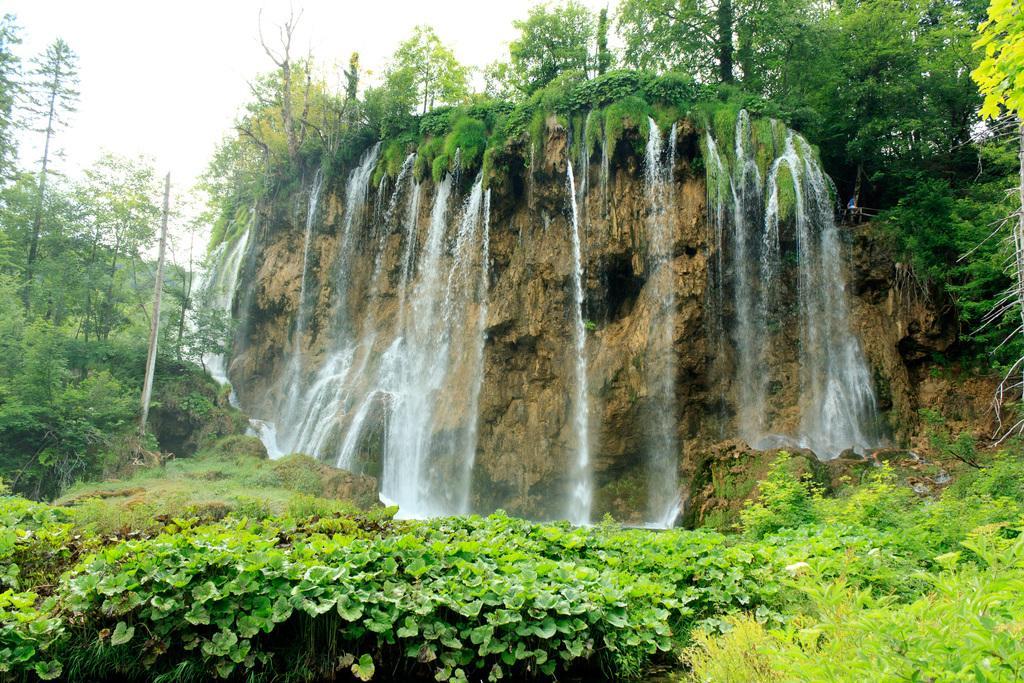Please provide a concise description of this image. In this picture we can see trees, waterfall and in the background we can see sky. 